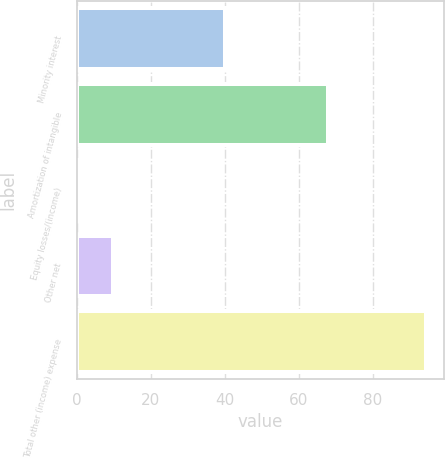<chart> <loc_0><loc_0><loc_500><loc_500><bar_chart><fcel>Minority interest<fcel>Amortization of intangible<fcel>Equity losses/(income)<fcel>Other net<fcel>Total other (income) expense<nl><fcel>40.1<fcel>68<fcel>0.2<fcel>9.63<fcel>94.5<nl></chart> 